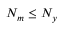Convert formula to latex. <formula><loc_0><loc_0><loc_500><loc_500>N _ { m } \leq N _ { y }</formula> 